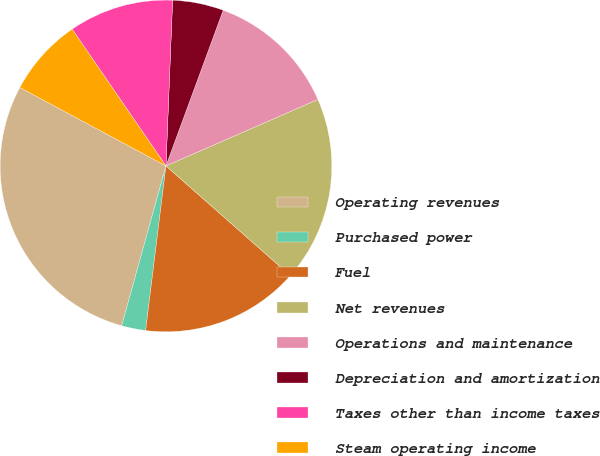<chart> <loc_0><loc_0><loc_500><loc_500><pie_chart><fcel>Operating revenues<fcel>Purchased power<fcel>Fuel<fcel>Net revenues<fcel>Operations and maintenance<fcel>Depreciation and amortization<fcel>Taxes other than income taxes<fcel>Steam operating income<nl><fcel>28.54%<fcel>2.35%<fcel>15.45%<fcel>18.07%<fcel>12.83%<fcel>4.97%<fcel>10.21%<fcel>7.59%<nl></chart> 